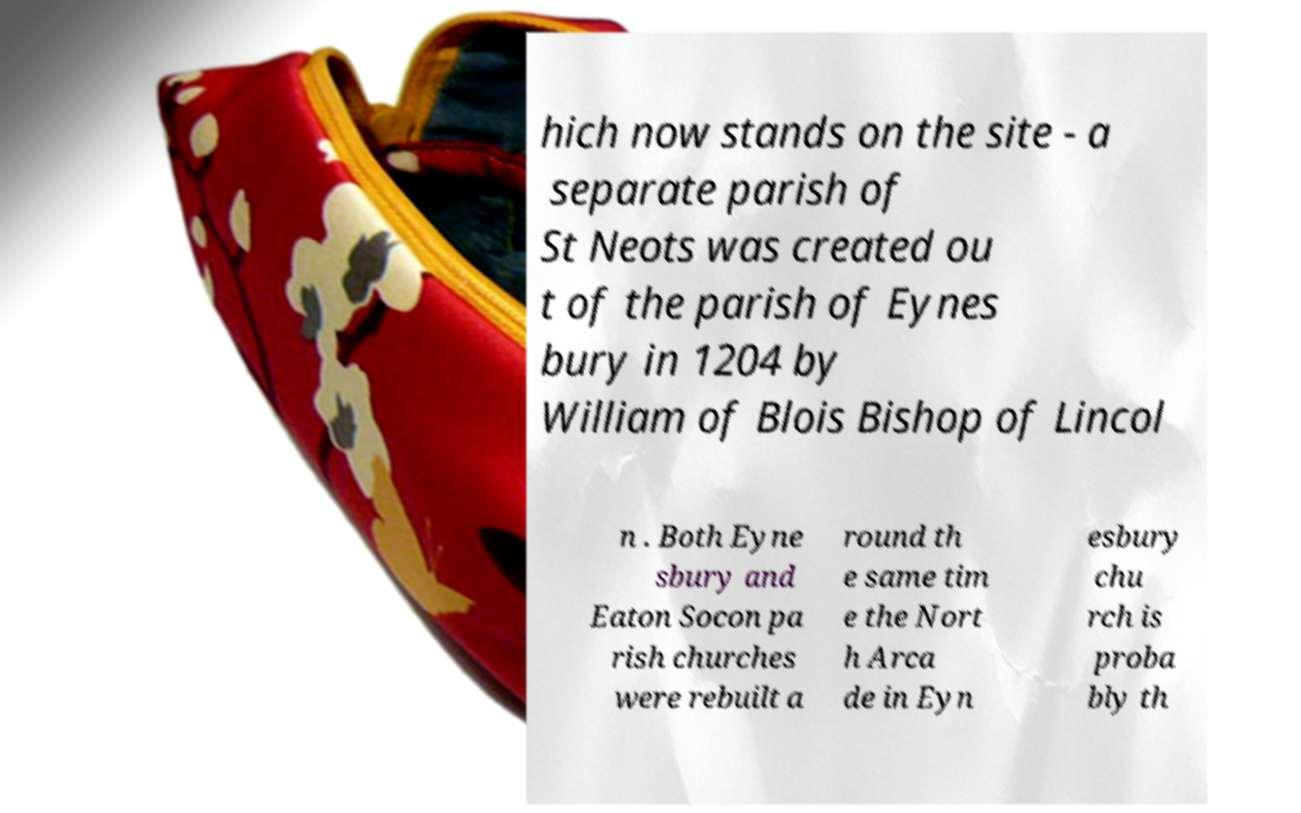Can you read and provide the text displayed in the image?This photo seems to have some interesting text. Can you extract and type it out for me? hich now stands on the site - a separate parish of St Neots was created ou t of the parish of Eynes bury in 1204 by William of Blois Bishop of Lincol n . Both Eyne sbury and Eaton Socon pa rish churches were rebuilt a round th e same tim e the Nort h Arca de in Eyn esbury chu rch is proba bly th 